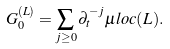Convert formula to latex. <formula><loc_0><loc_0><loc_500><loc_500>G _ { 0 } ^ { ( L ) } = \sum _ { j \geq 0 } \partial _ { t } ^ { - j } \mu l o c ( L ) .</formula> 